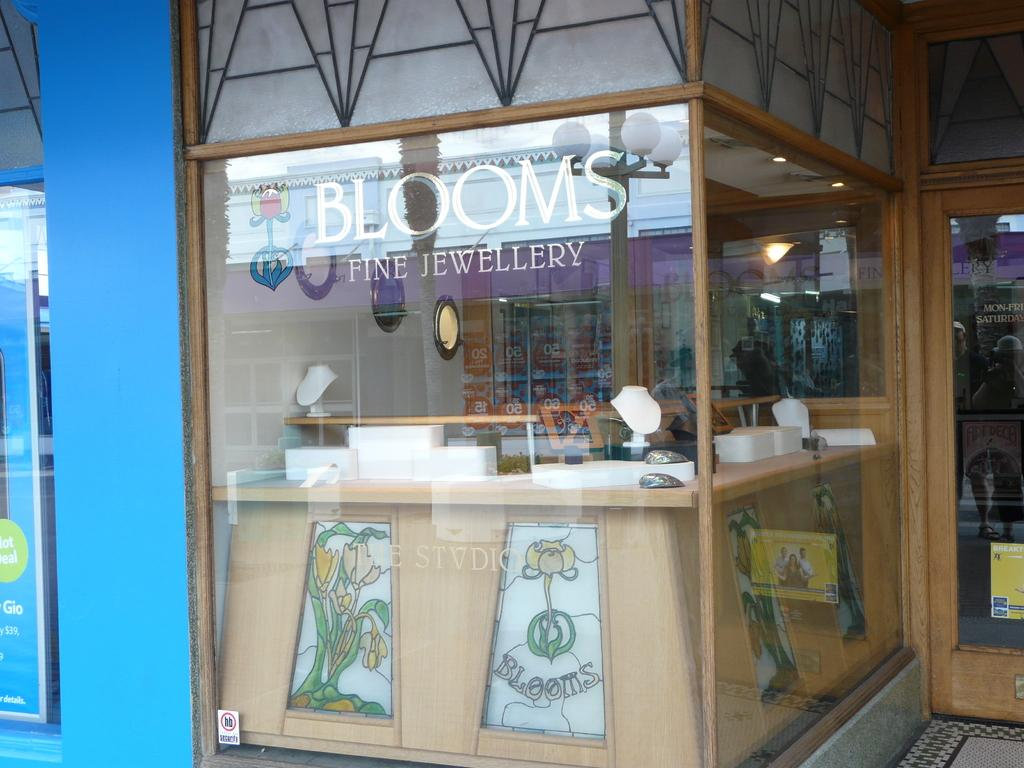<image>
Render a clear and concise summary of the photo. Store stand for Blooms Fine Jewellery showing some drawings in the front. 